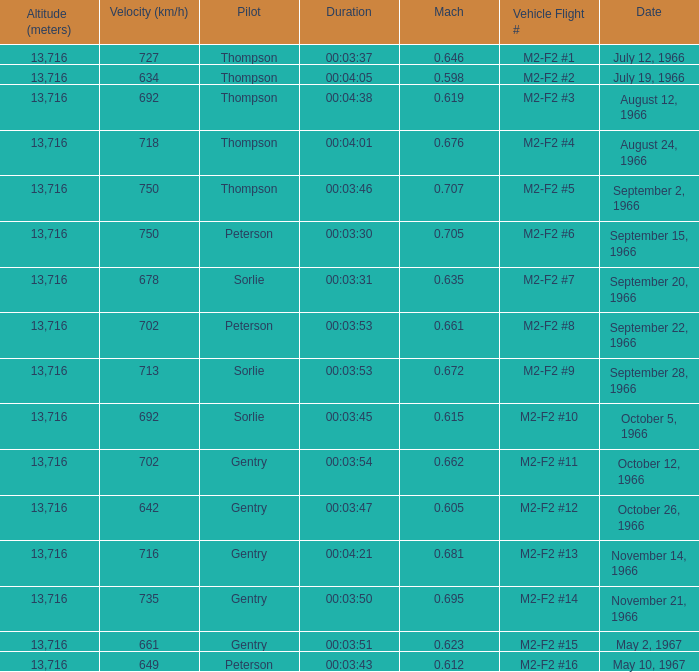What is the Mach with Vehicle Flight # m2-f2 #8 and an Altitude (meters) greater than 13,716? None. Parse the table in full. {'header': ['Altitude (meters)', 'Velocity (km/h)', 'Pilot', 'Duration', 'Mach', 'Vehicle Flight #', 'Date'], 'rows': [['13,716', '727', 'Thompson', '00:03:37', '0.646', 'M2-F2 #1', 'July 12, 1966'], ['13,716', '634', 'Thompson', '00:04:05', '0.598', 'M2-F2 #2', 'July 19, 1966'], ['13,716', '692', 'Thompson', '00:04:38', '0.619', 'M2-F2 #3', 'August 12, 1966'], ['13,716', '718', 'Thompson', '00:04:01', '0.676', 'M2-F2 #4', 'August 24, 1966'], ['13,716', '750', 'Thompson', '00:03:46', '0.707', 'M2-F2 #5', 'September 2, 1966'], ['13,716', '750', 'Peterson', '00:03:30', '0.705', 'M2-F2 #6', 'September 15, 1966'], ['13,716', '678', 'Sorlie', '00:03:31', '0.635', 'M2-F2 #7', 'September 20, 1966'], ['13,716', '702', 'Peterson', '00:03:53', '0.661', 'M2-F2 #8', 'September 22, 1966'], ['13,716', '713', 'Sorlie', '00:03:53', '0.672', 'M2-F2 #9', 'September 28, 1966'], ['13,716', '692', 'Sorlie', '00:03:45', '0.615', 'M2-F2 #10', 'October 5, 1966'], ['13,716', '702', 'Gentry', '00:03:54', '0.662', 'M2-F2 #11', 'October 12, 1966'], ['13,716', '642', 'Gentry', '00:03:47', '0.605', 'M2-F2 #12', 'October 26, 1966'], ['13,716', '716', 'Gentry', '00:04:21', '0.681', 'M2-F2 #13', 'November 14, 1966'], ['13,716', '735', 'Gentry', '00:03:50', '0.695', 'M2-F2 #14', 'November 21, 1966'], ['13,716', '661', 'Gentry', '00:03:51', '0.623', 'M2-F2 #15', 'May 2, 1967'], ['13,716', '649', 'Peterson', '00:03:43', '0.612', 'M2-F2 #16', 'May 10, 1967']]} 